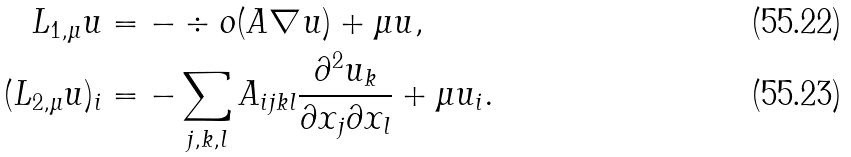<formula> <loc_0><loc_0><loc_500><loc_500>L _ { 1 , \mu } u & = - \div o ( A \nabla u ) + \mu u , \\ ( L _ { 2 , \mu } u ) _ { i } & = - \sum _ { j , k , l } A _ { i j k l } \frac { \partial ^ { 2 } u _ { k } } { \partial x _ { j } \partial x _ { l } } + \mu u _ { i } .</formula> 